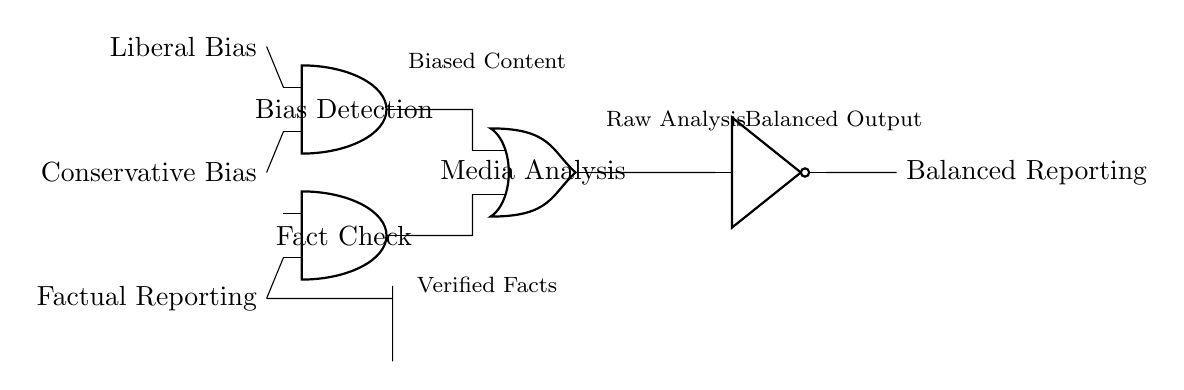What are the input variables for this circuit? The input variables are Liberal Bias, Conservative Bias, and Factual Reporting, which are represented at the left side of the circuit diagram.
Answer: Liberal Bias, Conservative Bias, Factual Reporting What type of logic gate is used for Bias Detection? An AND gate is used for Bias Detection, as indicated by the label on the gate's symbol in the diagram.
Answer: AND gate What is the output of the Media Analysis gate? The output of the Media Analysis gate is linked to the Balanced Reporting output, which is shown on the right side of the circuit.
Answer: Balanced Reporting How many logic gates are present in the circuit? There are three logic gates present in the circuit: two AND gates and one OR gate, which can be counted from the diagram.
Answer: Three What does the NOT gate signify in this circuit? The NOT gate signifies an inversion of the output from the OR gate, affecting the final output to ensure balanced reporting.
Answer: Inversion What is the purpose of the AND gate labeled Fact Check? The AND gate labeled Fact Check is used to validate the factual accuracy of reporting based on the input from Factual Reporting.
Answer: Validate factual accuracy Which component connects the AND gates to the OR gate? The output of both AND gates connects to the OR gate, as shown by the lines linking their outputs to the inputs of the OR gate in the diagram.
Answer: Output connections 